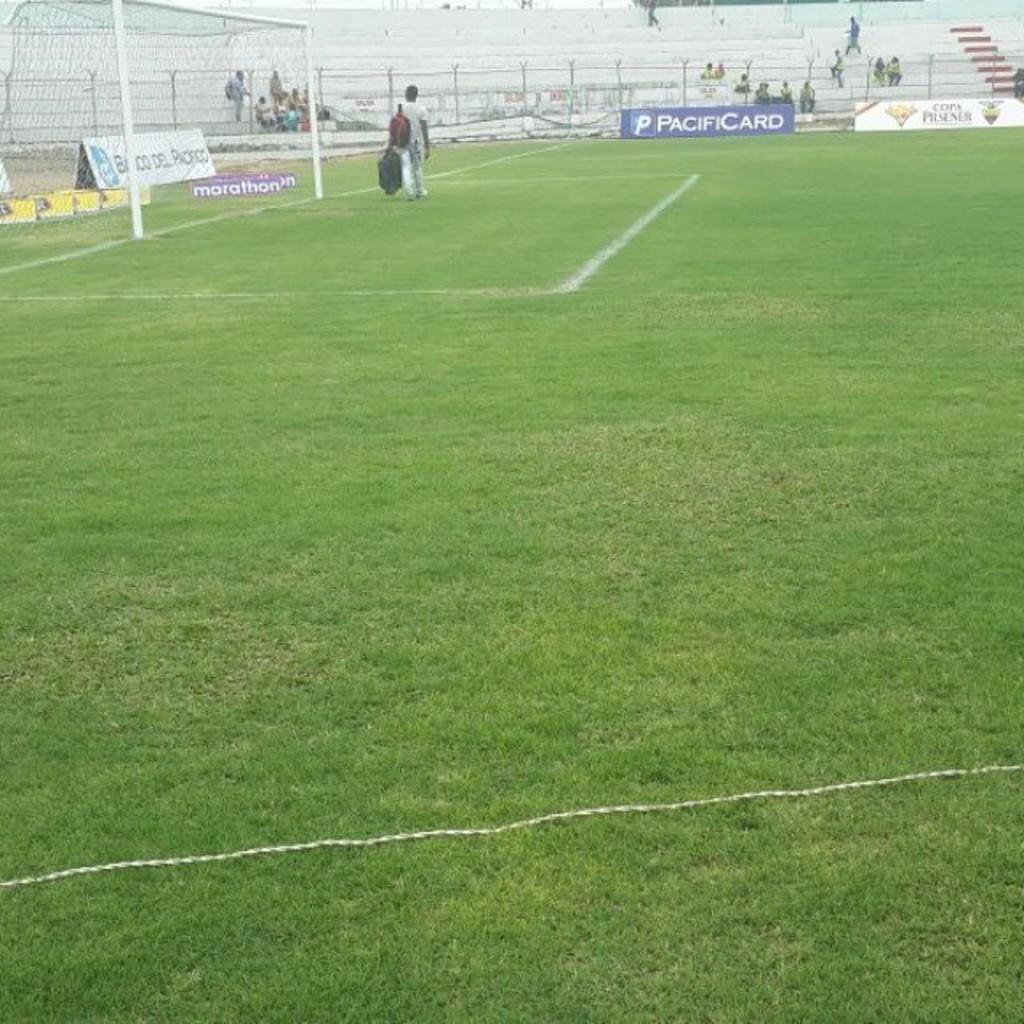What company is being advertised on the blue billboard?
Give a very brief answer. Pacificard. 